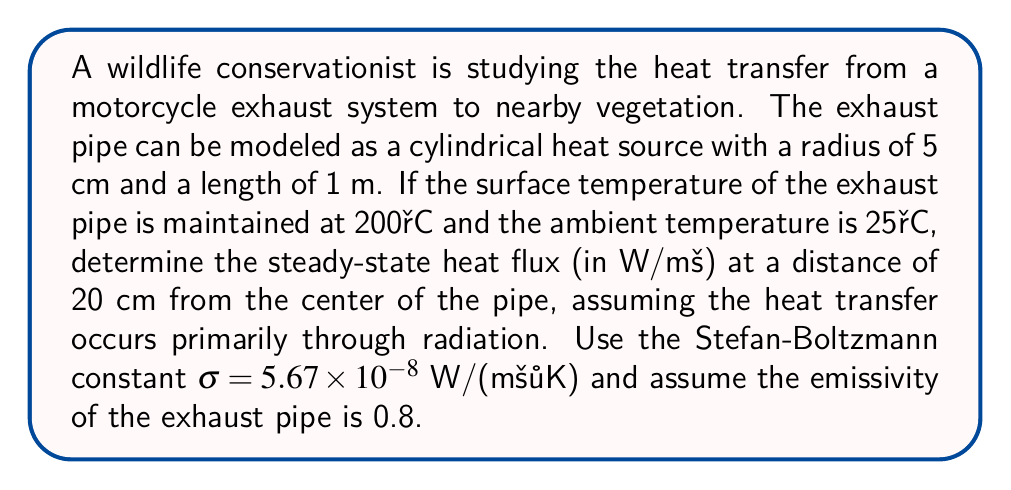Provide a solution to this math problem. To solve this problem, we'll use the Stefan-Boltzmann law for radiative heat transfer. The steps are as follows:

1) The Stefan-Boltzmann law for radiative heat flux is given by:

   $$q = \epsilon \sigma (T_1^4 - T_2^4)$$

   where:
   $q$ is the heat flux (W/m²)
   $\epsilon$ is the emissivity
   $\sigma$ is the Stefan-Boltzmann constant
   $T_1$ is the temperature of the hot surface (K)
   $T_2$ is the temperature of the surroundings (K)

2) Convert temperatures to Kelvin:
   $T_1 = 200°C + 273.15 = 473.15$ K
   $T_2 = 25°C + 273.15 = 298.15$ K

3) The heat flux at 20 cm from the center of the pipe will be reduced due to the inverse square law. The ratio of the areas will be:

   $$\left(\frac{r_1}{r_2}\right)^2 = \left(\frac{0.05}{0.20}\right)^2 = 0.0625$$

4) Now we can calculate the heat flux:

   $$q = 0.8 \times 5.67 \times 10^{-8} \times (473.15^4 - 298.15^4) \times 0.0625$$

5) Compute the result:
   $$q = 0.8 \times 5.67 \times 10^{-8} \times (5.0168 \times 10^{10} - 7.9039 \times 10^9) \times 0.0625$$
   $$q = 1,340.7 \text{ W/m²}$$
Answer: 1,340.7 W/m² 